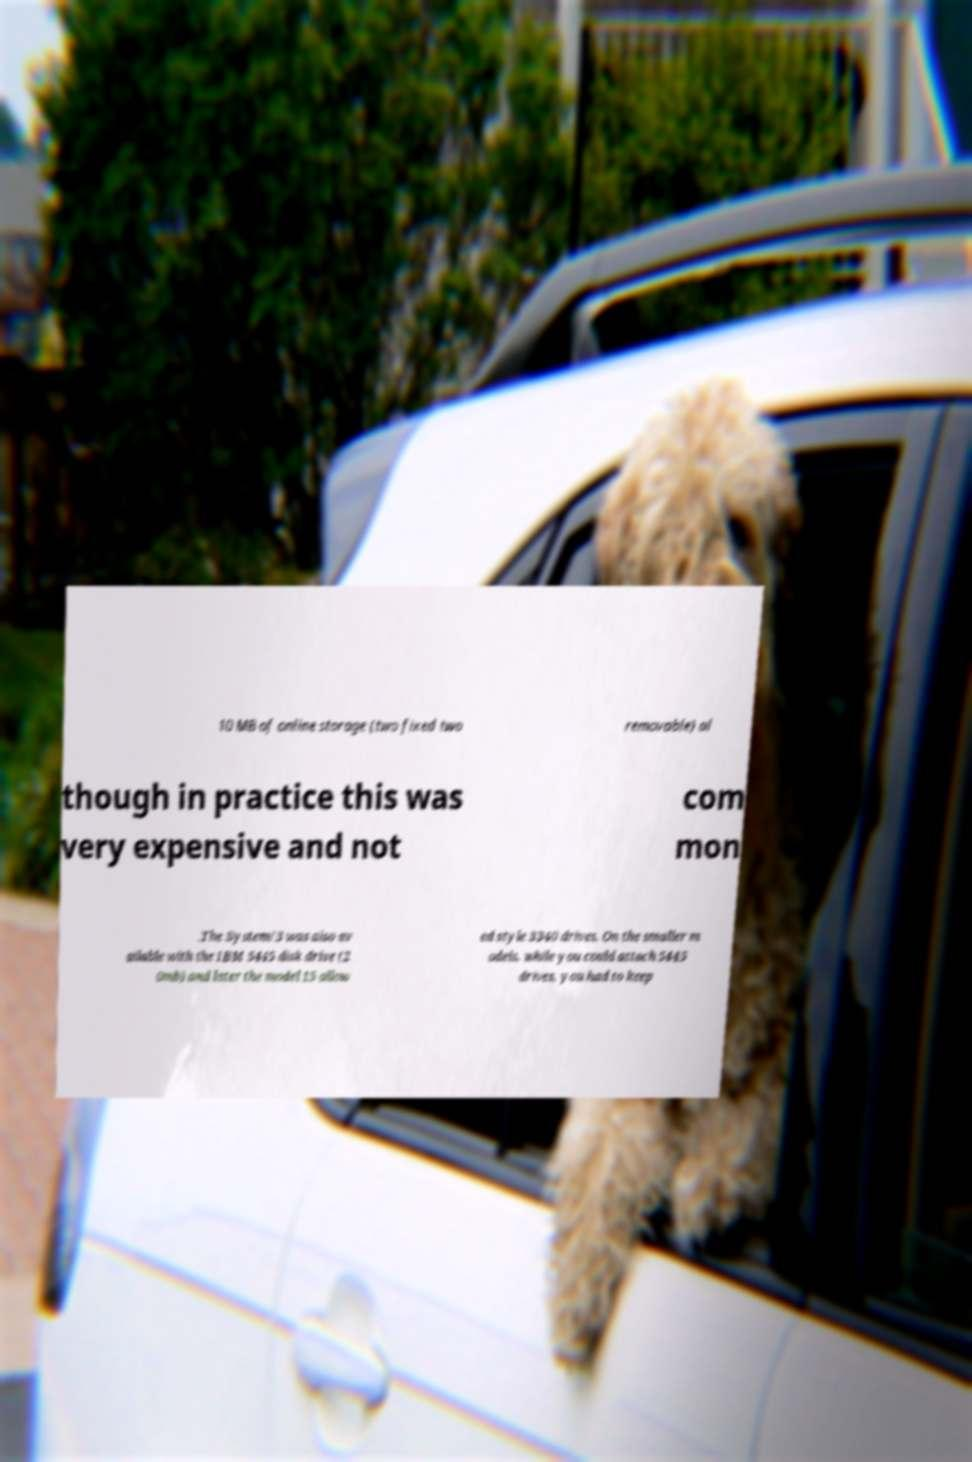Could you extract and type out the text from this image? 10 MB of online storage (two fixed two removable) al though in practice this was very expensive and not com mon .The System/3 was also av ailable with the IBM 5445 disk drive (2 0mb) and later the model 15 allow ed style 3340 drives. On the smaller m odels, while you could attach 5445 drives, you had to keep 